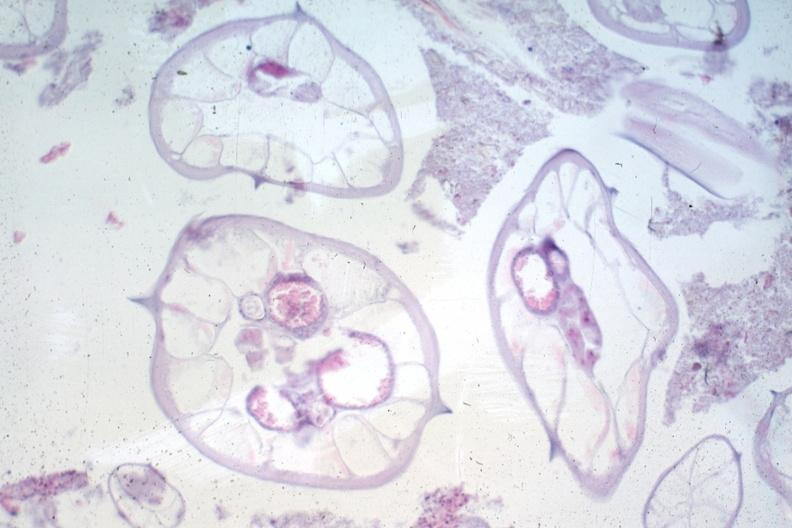s autoimmune thyroiditis present?
Answer the question using a single word or phrase. No 